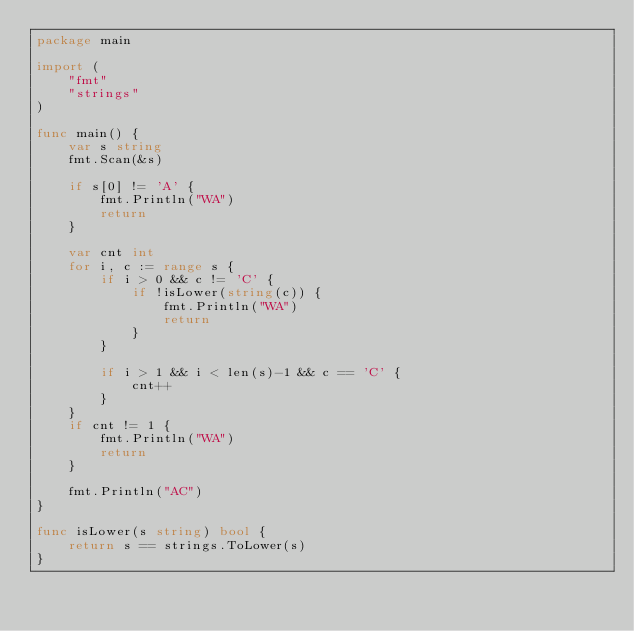Convert code to text. <code><loc_0><loc_0><loc_500><loc_500><_Go_>package main

import (
	"fmt"
	"strings"
)

func main() {
	var s string
	fmt.Scan(&s)

	if s[0] != 'A' {
		fmt.Println("WA")
		return
	}

	var cnt int
	for i, c := range s {
		if i > 0 && c != 'C' {
			if !isLower(string(c)) {
				fmt.Println("WA")
				return
			}
		}

		if i > 1 && i < len(s)-1 && c == 'C' {
			cnt++
		}
	}
	if cnt != 1 {
		fmt.Println("WA")
		return
	}

	fmt.Println("AC")
}

func isLower(s string) bool {
	return s == strings.ToLower(s)
}
</code> 